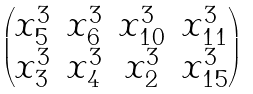<formula> <loc_0><loc_0><loc_500><loc_500>\begin{pmatrix} x _ { 5 } ^ { 3 } & x _ { 6 } ^ { 3 } & x _ { 1 0 } ^ { 3 } & x _ { 1 1 } ^ { 3 } \\ x _ { 3 } ^ { 3 } & x _ { 4 } ^ { 3 } & x _ { 2 } ^ { 3 } & x _ { 1 5 } ^ { 3 } \end{pmatrix}</formula> 